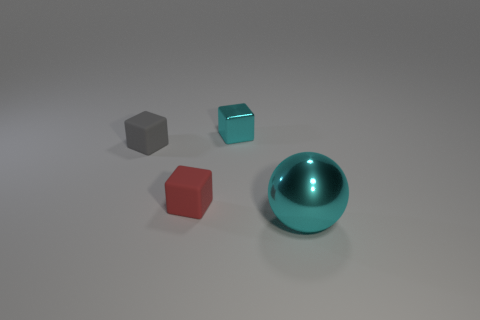Add 3 large blue cylinders. How many objects exist? 7 Subtract all blocks. How many objects are left? 1 Add 2 red objects. How many red objects exist? 3 Subtract 0 cyan cylinders. How many objects are left? 4 Subtract all cyan metallic spheres. Subtract all small red rubber cubes. How many objects are left? 2 Add 2 big objects. How many big objects are left? 3 